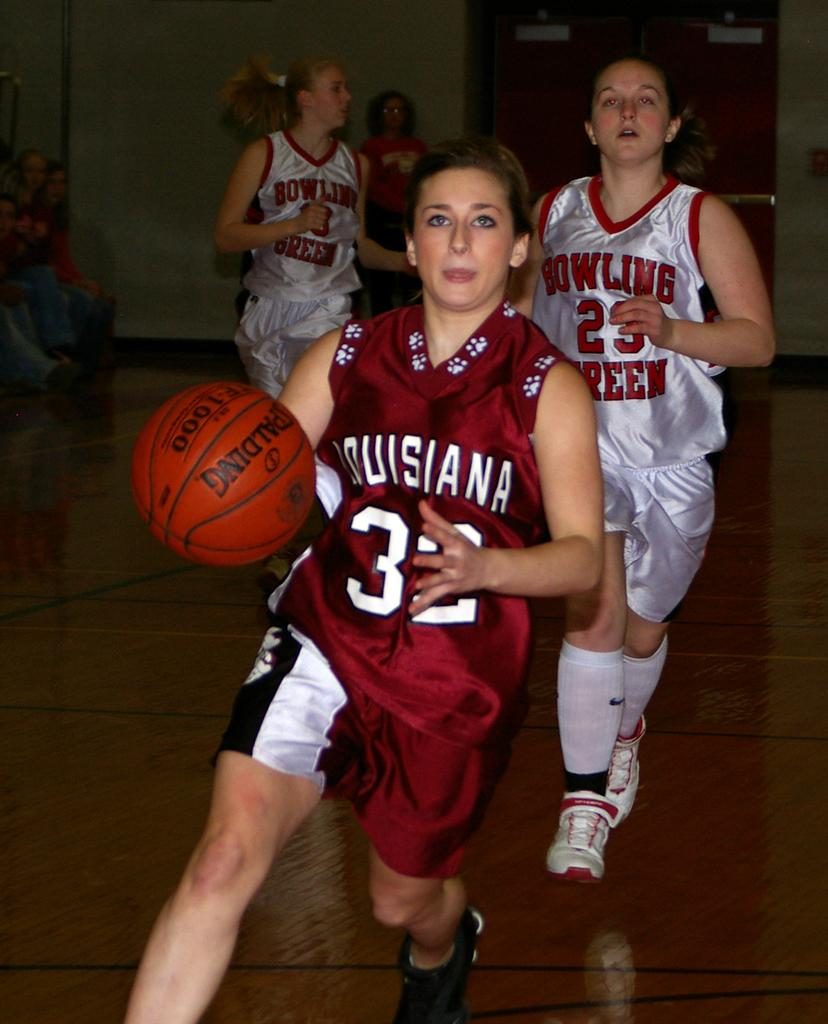<image>
Relay a brief, clear account of the picture shown. A woman basketball player wearing number 32 is being chased by a player of the opposing team. 